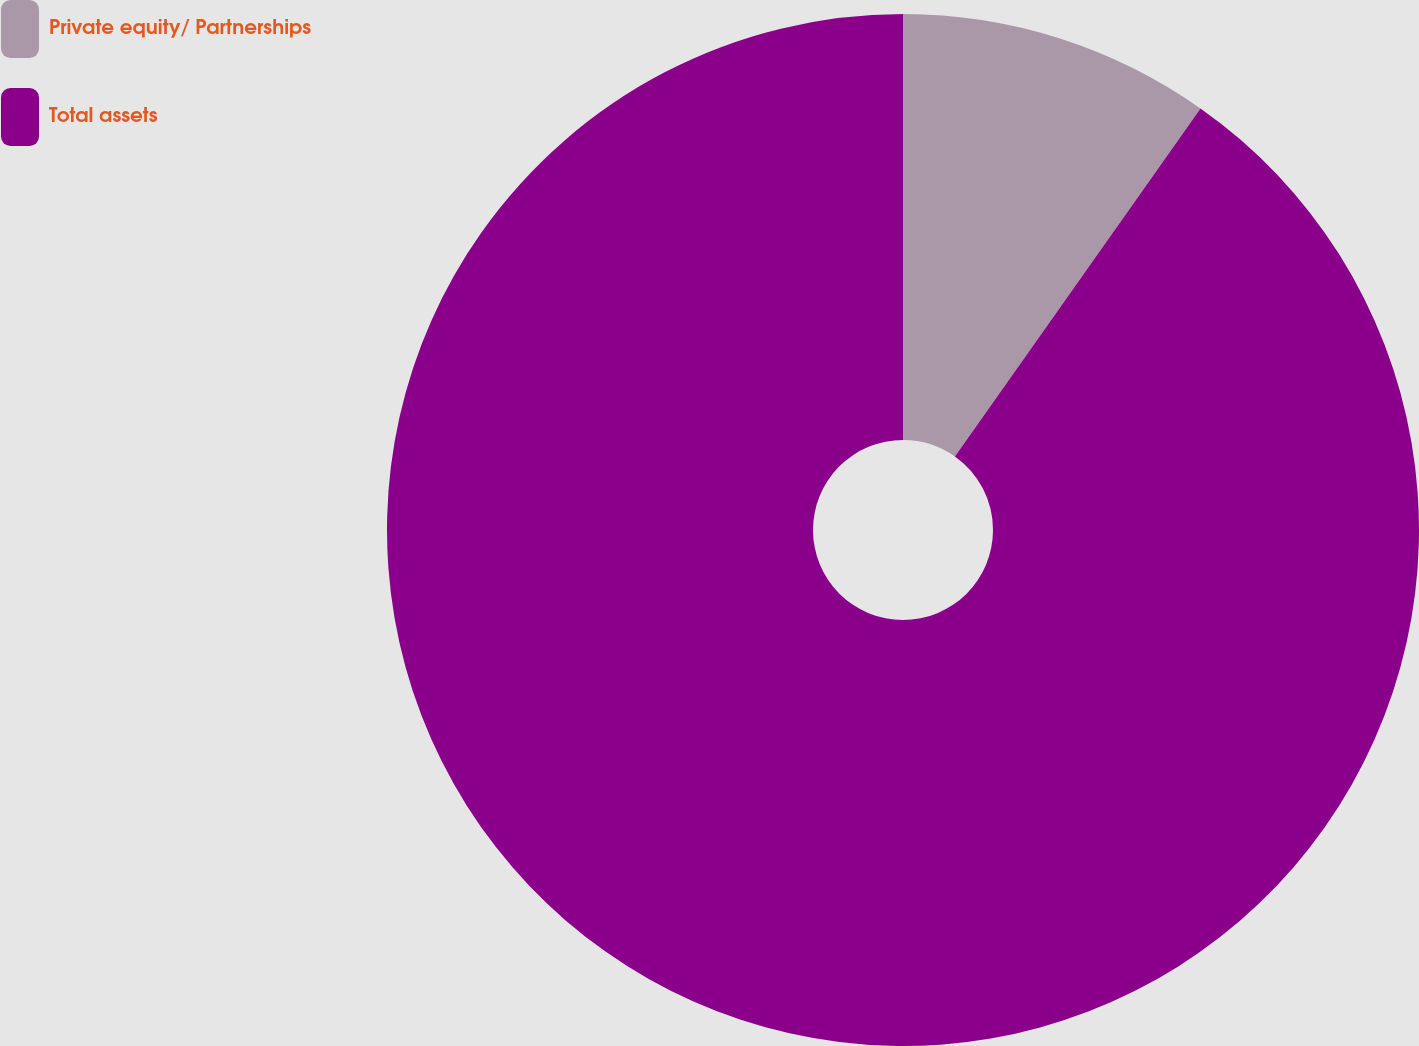<chart> <loc_0><loc_0><loc_500><loc_500><pie_chart><fcel>Private equity/ Partnerships<fcel>Total assets<nl><fcel>9.78%<fcel>90.22%<nl></chart> 